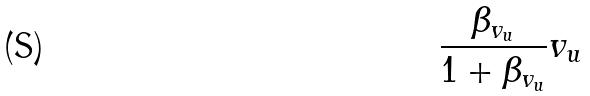<formula> <loc_0><loc_0><loc_500><loc_500>\frac { \beta _ { v _ { u } } } { 1 + \beta _ { v _ { u } } } v _ { u }</formula> 